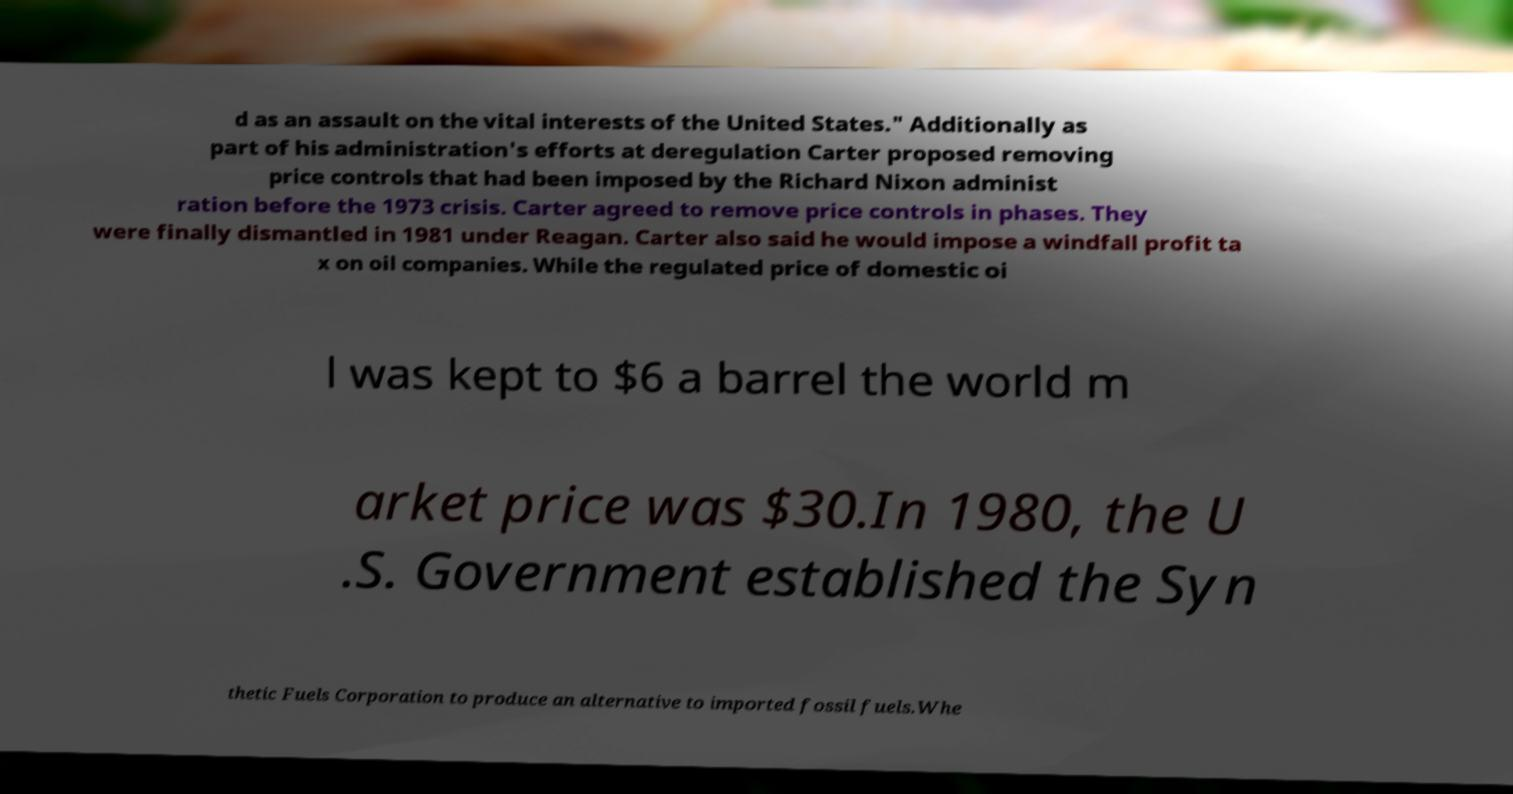Please read and relay the text visible in this image. What does it say? d as an assault on the vital interests of the United States." Additionally as part of his administration's efforts at deregulation Carter proposed removing price controls that had been imposed by the Richard Nixon administ ration before the 1973 crisis. Carter agreed to remove price controls in phases. They were finally dismantled in 1981 under Reagan. Carter also said he would impose a windfall profit ta x on oil companies. While the regulated price of domestic oi l was kept to $6 a barrel the world m arket price was $30.In 1980, the U .S. Government established the Syn thetic Fuels Corporation to produce an alternative to imported fossil fuels.Whe 